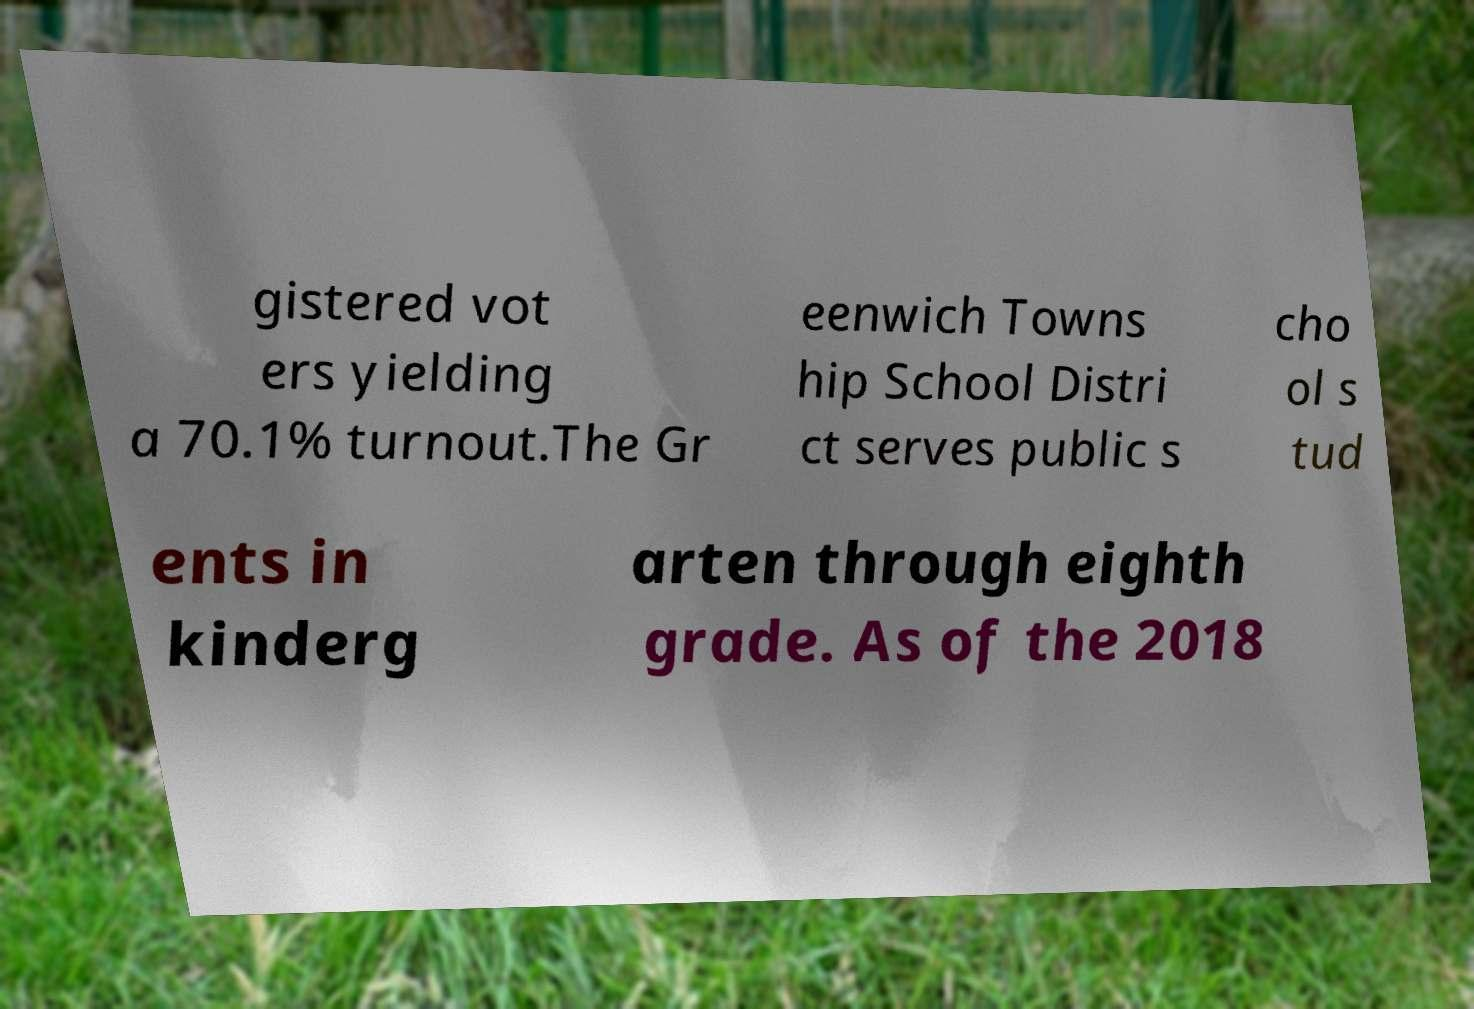There's text embedded in this image that I need extracted. Can you transcribe it verbatim? gistered vot ers yielding a 70.1% turnout.The Gr eenwich Towns hip School Distri ct serves public s cho ol s tud ents in kinderg arten through eighth grade. As of the 2018 